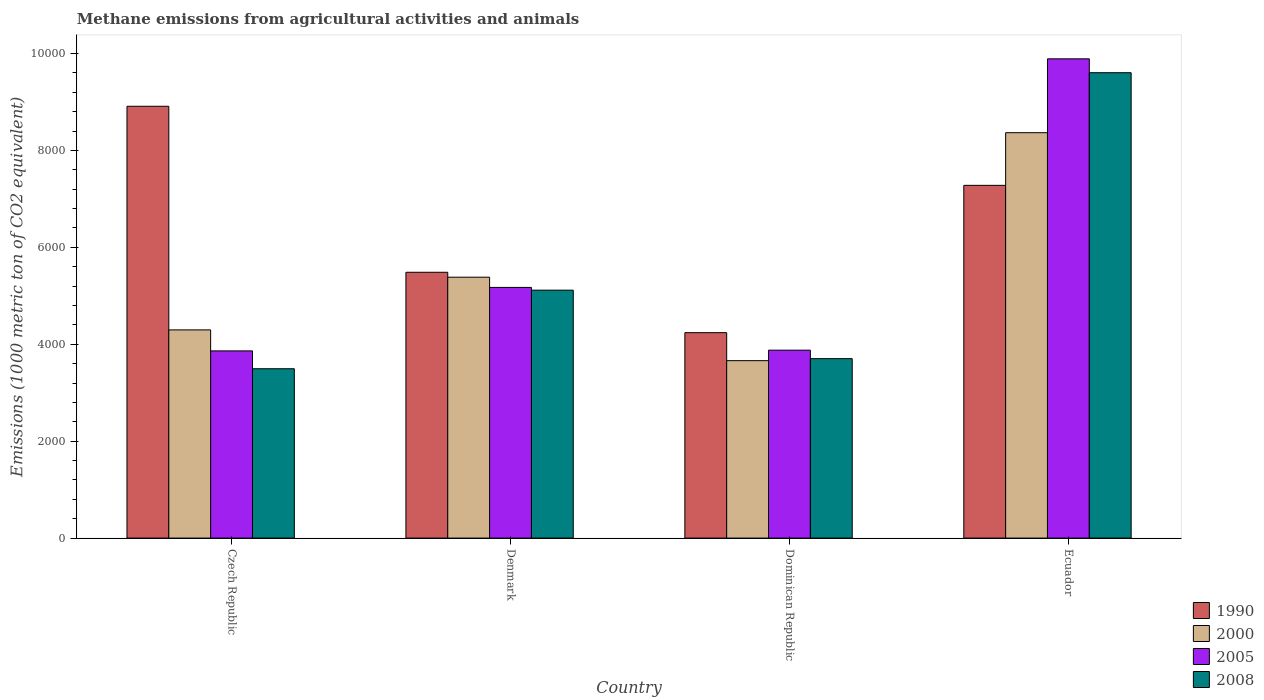How many groups of bars are there?
Ensure brevity in your answer.  4. Are the number of bars per tick equal to the number of legend labels?
Ensure brevity in your answer.  Yes. What is the label of the 1st group of bars from the left?
Offer a very short reply. Czech Republic. What is the amount of methane emitted in 2000 in Dominican Republic?
Offer a very short reply. 3661.8. Across all countries, what is the maximum amount of methane emitted in 2005?
Keep it short and to the point. 9891. Across all countries, what is the minimum amount of methane emitted in 2000?
Your answer should be very brief. 3661.8. In which country was the amount of methane emitted in 2000 maximum?
Make the answer very short. Ecuador. In which country was the amount of methane emitted in 1990 minimum?
Your answer should be compact. Dominican Republic. What is the total amount of methane emitted in 2000 in the graph?
Offer a very short reply. 2.17e+04. What is the difference between the amount of methane emitted in 2000 in Czech Republic and that in Dominican Republic?
Your answer should be very brief. 634.9. What is the difference between the amount of methane emitted in 1990 in Czech Republic and the amount of methane emitted in 2000 in Dominican Republic?
Your answer should be compact. 5250.2. What is the average amount of methane emitted in 2005 per country?
Provide a short and direct response. 5701.62. What is the difference between the amount of methane emitted of/in 2000 and amount of methane emitted of/in 2005 in Denmark?
Make the answer very short. 211.1. What is the ratio of the amount of methane emitted in 2000 in Denmark to that in Ecuador?
Ensure brevity in your answer.  0.64. Is the amount of methane emitted in 2000 in Czech Republic less than that in Denmark?
Your answer should be compact. Yes. Is the difference between the amount of methane emitted in 2000 in Czech Republic and Dominican Republic greater than the difference between the amount of methane emitted in 2005 in Czech Republic and Dominican Republic?
Offer a very short reply. Yes. What is the difference between the highest and the second highest amount of methane emitted in 2008?
Make the answer very short. -4488.1. What is the difference between the highest and the lowest amount of methane emitted in 1990?
Keep it short and to the point. 4672.2. What does the 4th bar from the left in Ecuador represents?
Offer a terse response. 2008. How many countries are there in the graph?
Provide a short and direct response. 4. Are the values on the major ticks of Y-axis written in scientific E-notation?
Your response must be concise. No. How many legend labels are there?
Offer a terse response. 4. How are the legend labels stacked?
Ensure brevity in your answer.  Vertical. What is the title of the graph?
Offer a terse response. Methane emissions from agricultural activities and animals. Does "1989" appear as one of the legend labels in the graph?
Provide a short and direct response. No. What is the label or title of the Y-axis?
Offer a terse response. Emissions (1000 metric ton of CO2 equivalent). What is the Emissions (1000 metric ton of CO2 equivalent) of 1990 in Czech Republic?
Offer a terse response. 8912. What is the Emissions (1000 metric ton of CO2 equivalent) of 2000 in Czech Republic?
Your response must be concise. 4296.7. What is the Emissions (1000 metric ton of CO2 equivalent) in 2005 in Czech Republic?
Make the answer very short. 3863.4. What is the Emissions (1000 metric ton of CO2 equivalent) in 2008 in Czech Republic?
Give a very brief answer. 3495.2. What is the Emissions (1000 metric ton of CO2 equivalent) in 1990 in Denmark?
Your response must be concise. 5486.2. What is the Emissions (1000 metric ton of CO2 equivalent) of 2000 in Denmark?
Give a very brief answer. 5384.6. What is the Emissions (1000 metric ton of CO2 equivalent) of 2005 in Denmark?
Provide a short and direct response. 5173.5. What is the Emissions (1000 metric ton of CO2 equivalent) of 2008 in Denmark?
Give a very brief answer. 5116.7. What is the Emissions (1000 metric ton of CO2 equivalent) of 1990 in Dominican Republic?
Make the answer very short. 4239.8. What is the Emissions (1000 metric ton of CO2 equivalent) of 2000 in Dominican Republic?
Ensure brevity in your answer.  3661.8. What is the Emissions (1000 metric ton of CO2 equivalent) in 2005 in Dominican Republic?
Offer a very short reply. 3878.6. What is the Emissions (1000 metric ton of CO2 equivalent) in 2008 in Dominican Republic?
Your answer should be very brief. 3703.5. What is the Emissions (1000 metric ton of CO2 equivalent) of 1990 in Ecuador?
Offer a very short reply. 7280. What is the Emissions (1000 metric ton of CO2 equivalent) of 2000 in Ecuador?
Your answer should be compact. 8366.7. What is the Emissions (1000 metric ton of CO2 equivalent) of 2005 in Ecuador?
Your answer should be compact. 9891. What is the Emissions (1000 metric ton of CO2 equivalent) in 2008 in Ecuador?
Your answer should be very brief. 9604.8. Across all countries, what is the maximum Emissions (1000 metric ton of CO2 equivalent) in 1990?
Give a very brief answer. 8912. Across all countries, what is the maximum Emissions (1000 metric ton of CO2 equivalent) in 2000?
Provide a succinct answer. 8366.7. Across all countries, what is the maximum Emissions (1000 metric ton of CO2 equivalent) in 2005?
Ensure brevity in your answer.  9891. Across all countries, what is the maximum Emissions (1000 metric ton of CO2 equivalent) in 2008?
Provide a short and direct response. 9604.8. Across all countries, what is the minimum Emissions (1000 metric ton of CO2 equivalent) in 1990?
Make the answer very short. 4239.8. Across all countries, what is the minimum Emissions (1000 metric ton of CO2 equivalent) of 2000?
Your answer should be very brief. 3661.8. Across all countries, what is the minimum Emissions (1000 metric ton of CO2 equivalent) in 2005?
Ensure brevity in your answer.  3863.4. Across all countries, what is the minimum Emissions (1000 metric ton of CO2 equivalent) of 2008?
Ensure brevity in your answer.  3495.2. What is the total Emissions (1000 metric ton of CO2 equivalent) in 1990 in the graph?
Provide a succinct answer. 2.59e+04. What is the total Emissions (1000 metric ton of CO2 equivalent) in 2000 in the graph?
Your answer should be compact. 2.17e+04. What is the total Emissions (1000 metric ton of CO2 equivalent) in 2005 in the graph?
Your answer should be very brief. 2.28e+04. What is the total Emissions (1000 metric ton of CO2 equivalent) of 2008 in the graph?
Keep it short and to the point. 2.19e+04. What is the difference between the Emissions (1000 metric ton of CO2 equivalent) in 1990 in Czech Republic and that in Denmark?
Offer a terse response. 3425.8. What is the difference between the Emissions (1000 metric ton of CO2 equivalent) of 2000 in Czech Republic and that in Denmark?
Your answer should be very brief. -1087.9. What is the difference between the Emissions (1000 metric ton of CO2 equivalent) of 2005 in Czech Republic and that in Denmark?
Ensure brevity in your answer.  -1310.1. What is the difference between the Emissions (1000 metric ton of CO2 equivalent) in 2008 in Czech Republic and that in Denmark?
Your answer should be compact. -1621.5. What is the difference between the Emissions (1000 metric ton of CO2 equivalent) in 1990 in Czech Republic and that in Dominican Republic?
Your answer should be very brief. 4672.2. What is the difference between the Emissions (1000 metric ton of CO2 equivalent) of 2000 in Czech Republic and that in Dominican Republic?
Provide a succinct answer. 634.9. What is the difference between the Emissions (1000 metric ton of CO2 equivalent) of 2005 in Czech Republic and that in Dominican Republic?
Keep it short and to the point. -15.2. What is the difference between the Emissions (1000 metric ton of CO2 equivalent) in 2008 in Czech Republic and that in Dominican Republic?
Keep it short and to the point. -208.3. What is the difference between the Emissions (1000 metric ton of CO2 equivalent) in 1990 in Czech Republic and that in Ecuador?
Provide a short and direct response. 1632. What is the difference between the Emissions (1000 metric ton of CO2 equivalent) of 2000 in Czech Republic and that in Ecuador?
Give a very brief answer. -4070. What is the difference between the Emissions (1000 metric ton of CO2 equivalent) in 2005 in Czech Republic and that in Ecuador?
Offer a terse response. -6027.6. What is the difference between the Emissions (1000 metric ton of CO2 equivalent) in 2008 in Czech Republic and that in Ecuador?
Give a very brief answer. -6109.6. What is the difference between the Emissions (1000 metric ton of CO2 equivalent) in 1990 in Denmark and that in Dominican Republic?
Your answer should be very brief. 1246.4. What is the difference between the Emissions (1000 metric ton of CO2 equivalent) in 2000 in Denmark and that in Dominican Republic?
Make the answer very short. 1722.8. What is the difference between the Emissions (1000 metric ton of CO2 equivalent) of 2005 in Denmark and that in Dominican Republic?
Your response must be concise. 1294.9. What is the difference between the Emissions (1000 metric ton of CO2 equivalent) in 2008 in Denmark and that in Dominican Republic?
Give a very brief answer. 1413.2. What is the difference between the Emissions (1000 metric ton of CO2 equivalent) of 1990 in Denmark and that in Ecuador?
Your response must be concise. -1793.8. What is the difference between the Emissions (1000 metric ton of CO2 equivalent) of 2000 in Denmark and that in Ecuador?
Ensure brevity in your answer.  -2982.1. What is the difference between the Emissions (1000 metric ton of CO2 equivalent) in 2005 in Denmark and that in Ecuador?
Provide a succinct answer. -4717.5. What is the difference between the Emissions (1000 metric ton of CO2 equivalent) in 2008 in Denmark and that in Ecuador?
Keep it short and to the point. -4488.1. What is the difference between the Emissions (1000 metric ton of CO2 equivalent) in 1990 in Dominican Republic and that in Ecuador?
Offer a very short reply. -3040.2. What is the difference between the Emissions (1000 metric ton of CO2 equivalent) in 2000 in Dominican Republic and that in Ecuador?
Provide a succinct answer. -4704.9. What is the difference between the Emissions (1000 metric ton of CO2 equivalent) of 2005 in Dominican Republic and that in Ecuador?
Give a very brief answer. -6012.4. What is the difference between the Emissions (1000 metric ton of CO2 equivalent) in 2008 in Dominican Republic and that in Ecuador?
Provide a succinct answer. -5901.3. What is the difference between the Emissions (1000 metric ton of CO2 equivalent) of 1990 in Czech Republic and the Emissions (1000 metric ton of CO2 equivalent) of 2000 in Denmark?
Your answer should be compact. 3527.4. What is the difference between the Emissions (1000 metric ton of CO2 equivalent) of 1990 in Czech Republic and the Emissions (1000 metric ton of CO2 equivalent) of 2005 in Denmark?
Give a very brief answer. 3738.5. What is the difference between the Emissions (1000 metric ton of CO2 equivalent) of 1990 in Czech Republic and the Emissions (1000 metric ton of CO2 equivalent) of 2008 in Denmark?
Ensure brevity in your answer.  3795.3. What is the difference between the Emissions (1000 metric ton of CO2 equivalent) in 2000 in Czech Republic and the Emissions (1000 metric ton of CO2 equivalent) in 2005 in Denmark?
Make the answer very short. -876.8. What is the difference between the Emissions (1000 metric ton of CO2 equivalent) of 2000 in Czech Republic and the Emissions (1000 metric ton of CO2 equivalent) of 2008 in Denmark?
Ensure brevity in your answer.  -820. What is the difference between the Emissions (1000 metric ton of CO2 equivalent) of 2005 in Czech Republic and the Emissions (1000 metric ton of CO2 equivalent) of 2008 in Denmark?
Provide a short and direct response. -1253.3. What is the difference between the Emissions (1000 metric ton of CO2 equivalent) in 1990 in Czech Republic and the Emissions (1000 metric ton of CO2 equivalent) in 2000 in Dominican Republic?
Ensure brevity in your answer.  5250.2. What is the difference between the Emissions (1000 metric ton of CO2 equivalent) of 1990 in Czech Republic and the Emissions (1000 metric ton of CO2 equivalent) of 2005 in Dominican Republic?
Provide a short and direct response. 5033.4. What is the difference between the Emissions (1000 metric ton of CO2 equivalent) in 1990 in Czech Republic and the Emissions (1000 metric ton of CO2 equivalent) in 2008 in Dominican Republic?
Your answer should be compact. 5208.5. What is the difference between the Emissions (1000 metric ton of CO2 equivalent) of 2000 in Czech Republic and the Emissions (1000 metric ton of CO2 equivalent) of 2005 in Dominican Republic?
Your answer should be very brief. 418.1. What is the difference between the Emissions (1000 metric ton of CO2 equivalent) of 2000 in Czech Republic and the Emissions (1000 metric ton of CO2 equivalent) of 2008 in Dominican Republic?
Your response must be concise. 593.2. What is the difference between the Emissions (1000 metric ton of CO2 equivalent) of 2005 in Czech Republic and the Emissions (1000 metric ton of CO2 equivalent) of 2008 in Dominican Republic?
Offer a terse response. 159.9. What is the difference between the Emissions (1000 metric ton of CO2 equivalent) in 1990 in Czech Republic and the Emissions (1000 metric ton of CO2 equivalent) in 2000 in Ecuador?
Your answer should be compact. 545.3. What is the difference between the Emissions (1000 metric ton of CO2 equivalent) of 1990 in Czech Republic and the Emissions (1000 metric ton of CO2 equivalent) of 2005 in Ecuador?
Your answer should be compact. -979. What is the difference between the Emissions (1000 metric ton of CO2 equivalent) in 1990 in Czech Republic and the Emissions (1000 metric ton of CO2 equivalent) in 2008 in Ecuador?
Your answer should be compact. -692.8. What is the difference between the Emissions (1000 metric ton of CO2 equivalent) in 2000 in Czech Republic and the Emissions (1000 metric ton of CO2 equivalent) in 2005 in Ecuador?
Provide a short and direct response. -5594.3. What is the difference between the Emissions (1000 metric ton of CO2 equivalent) of 2000 in Czech Republic and the Emissions (1000 metric ton of CO2 equivalent) of 2008 in Ecuador?
Provide a succinct answer. -5308.1. What is the difference between the Emissions (1000 metric ton of CO2 equivalent) in 2005 in Czech Republic and the Emissions (1000 metric ton of CO2 equivalent) in 2008 in Ecuador?
Offer a very short reply. -5741.4. What is the difference between the Emissions (1000 metric ton of CO2 equivalent) in 1990 in Denmark and the Emissions (1000 metric ton of CO2 equivalent) in 2000 in Dominican Republic?
Offer a very short reply. 1824.4. What is the difference between the Emissions (1000 metric ton of CO2 equivalent) in 1990 in Denmark and the Emissions (1000 metric ton of CO2 equivalent) in 2005 in Dominican Republic?
Give a very brief answer. 1607.6. What is the difference between the Emissions (1000 metric ton of CO2 equivalent) of 1990 in Denmark and the Emissions (1000 metric ton of CO2 equivalent) of 2008 in Dominican Republic?
Your answer should be very brief. 1782.7. What is the difference between the Emissions (1000 metric ton of CO2 equivalent) in 2000 in Denmark and the Emissions (1000 metric ton of CO2 equivalent) in 2005 in Dominican Republic?
Your answer should be compact. 1506. What is the difference between the Emissions (1000 metric ton of CO2 equivalent) of 2000 in Denmark and the Emissions (1000 metric ton of CO2 equivalent) of 2008 in Dominican Republic?
Make the answer very short. 1681.1. What is the difference between the Emissions (1000 metric ton of CO2 equivalent) of 2005 in Denmark and the Emissions (1000 metric ton of CO2 equivalent) of 2008 in Dominican Republic?
Your answer should be very brief. 1470. What is the difference between the Emissions (1000 metric ton of CO2 equivalent) of 1990 in Denmark and the Emissions (1000 metric ton of CO2 equivalent) of 2000 in Ecuador?
Ensure brevity in your answer.  -2880.5. What is the difference between the Emissions (1000 metric ton of CO2 equivalent) of 1990 in Denmark and the Emissions (1000 metric ton of CO2 equivalent) of 2005 in Ecuador?
Offer a very short reply. -4404.8. What is the difference between the Emissions (1000 metric ton of CO2 equivalent) of 1990 in Denmark and the Emissions (1000 metric ton of CO2 equivalent) of 2008 in Ecuador?
Your answer should be compact. -4118.6. What is the difference between the Emissions (1000 metric ton of CO2 equivalent) in 2000 in Denmark and the Emissions (1000 metric ton of CO2 equivalent) in 2005 in Ecuador?
Provide a succinct answer. -4506.4. What is the difference between the Emissions (1000 metric ton of CO2 equivalent) of 2000 in Denmark and the Emissions (1000 metric ton of CO2 equivalent) of 2008 in Ecuador?
Your response must be concise. -4220.2. What is the difference between the Emissions (1000 metric ton of CO2 equivalent) of 2005 in Denmark and the Emissions (1000 metric ton of CO2 equivalent) of 2008 in Ecuador?
Provide a short and direct response. -4431.3. What is the difference between the Emissions (1000 metric ton of CO2 equivalent) in 1990 in Dominican Republic and the Emissions (1000 metric ton of CO2 equivalent) in 2000 in Ecuador?
Ensure brevity in your answer.  -4126.9. What is the difference between the Emissions (1000 metric ton of CO2 equivalent) of 1990 in Dominican Republic and the Emissions (1000 metric ton of CO2 equivalent) of 2005 in Ecuador?
Give a very brief answer. -5651.2. What is the difference between the Emissions (1000 metric ton of CO2 equivalent) of 1990 in Dominican Republic and the Emissions (1000 metric ton of CO2 equivalent) of 2008 in Ecuador?
Your response must be concise. -5365. What is the difference between the Emissions (1000 metric ton of CO2 equivalent) in 2000 in Dominican Republic and the Emissions (1000 metric ton of CO2 equivalent) in 2005 in Ecuador?
Your answer should be compact. -6229.2. What is the difference between the Emissions (1000 metric ton of CO2 equivalent) of 2000 in Dominican Republic and the Emissions (1000 metric ton of CO2 equivalent) of 2008 in Ecuador?
Give a very brief answer. -5943. What is the difference between the Emissions (1000 metric ton of CO2 equivalent) in 2005 in Dominican Republic and the Emissions (1000 metric ton of CO2 equivalent) in 2008 in Ecuador?
Give a very brief answer. -5726.2. What is the average Emissions (1000 metric ton of CO2 equivalent) of 1990 per country?
Provide a succinct answer. 6479.5. What is the average Emissions (1000 metric ton of CO2 equivalent) in 2000 per country?
Give a very brief answer. 5427.45. What is the average Emissions (1000 metric ton of CO2 equivalent) in 2005 per country?
Keep it short and to the point. 5701.62. What is the average Emissions (1000 metric ton of CO2 equivalent) in 2008 per country?
Offer a very short reply. 5480.05. What is the difference between the Emissions (1000 metric ton of CO2 equivalent) of 1990 and Emissions (1000 metric ton of CO2 equivalent) of 2000 in Czech Republic?
Ensure brevity in your answer.  4615.3. What is the difference between the Emissions (1000 metric ton of CO2 equivalent) in 1990 and Emissions (1000 metric ton of CO2 equivalent) in 2005 in Czech Republic?
Keep it short and to the point. 5048.6. What is the difference between the Emissions (1000 metric ton of CO2 equivalent) in 1990 and Emissions (1000 metric ton of CO2 equivalent) in 2008 in Czech Republic?
Ensure brevity in your answer.  5416.8. What is the difference between the Emissions (1000 metric ton of CO2 equivalent) of 2000 and Emissions (1000 metric ton of CO2 equivalent) of 2005 in Czech Republic?
Provide a short and direct response. 433.3. What is the difference between the Emissions (1000 metric ton of CO2 equivalent) of 2000 and Emissions (1000 metric ton of CO2 equivalent) of 2008 in Czech Republic?
Keep it short and to the point. 801.5. What is the difference between the Emissions (1000 metric ton of CO2 equivalent) of 2005 and Emissions (1000 metric ton of CO2 equivalent) of 2008 in Czech Republic?
Your answer should be very brief. 368.2. What is the difference between the Emissions (1000 metric ton of CO2 equivalent) in 1990 and Emissions (1000 metric ton of CO2 equivalent) in 2000 in Denmark?
Your response must be concise. 101.6. What is the difference between the Emissions (1000 metric ton of CO2 equivalent) in 1990 and Emissions (1000 metric ton of CO2 equivalent) in 2005 in Denmark?
Ensure brevity in your answer.  312.7. What is the difference between the Emissions (1000 metric ton of CO2 equivalent) in 1990 and Emissions (1000 metric ton of CO2 equivalent) in 2008 in Denmark?
Provide a succinct answer. 369.5. What is the difference between the Emissions (1000 metric ton of CO2 equivalent) of 2000 and Emissions (1000 metric ton of CO2 equivalent) of 2005 in Denmark?
Provide a succinct answer. 211.1. What is the difference between the Emissions (1000 metric ton of CO2 equivalent) in 2000 and Emissions (1000 metric ton of CO2 equivalent) in 2008 in Denmark?
Your answer should be compact. 267.9. What is the difference between the Emissions (1000 metric ton of CO2 equivalent) in 2005 and Emissions (1000 metric ton of CO2 equivalent) in 2008 in Denmark?
Make the answer very short. 56.8. What is the difference between the Emissions (1000 metric ton of CO2 equivalent) in 1990 and Emissions (1000 metric ton of CO2 equivalent) in 2000 in Dominican Republic?
Keep it short and to the point. 578. What is the difference between the Emissions (1000 metric ton of CO2 equivalent) in 1990 and Emissions (1000 metric ton of CO2 equivalent) in 2005 in Dominican Republic?
Your response must be concise. 361.2. What is the difference between the Emissions (1000 metric ton of CO2 equivalent) in 1990 and Emissions (1000 metric ton of CO2 equivalent) in 2008 in Dominican Republic?
Your answer should be compact. 536.3. What is the difference between the Emissions (1000 metric ton of CO2 equivalent) in 2000 and Emissions (1000 metric ton of CO2 equivalent) in 2005 in Dominican Republic?
Your answer should be very brief. -216.8. What is the difference between the Emissions (1000 metric ton of CO2 equivalent) in 2000 and Emissions (1000 metric ton of CO2 equivalent) in 2008 in Dominican Republic?
Keep it short and to the point. -41.7. What is the difference between the Emissions (1000 metric ton of CO2 equivalent) of 2005 and Emissions (1000 metric ton of CO2 equivalent) of 2008 in Dominican Republic?
Your response must be concise. 175.1. What is the difference between the Emissions (1000 metric ton of CO2 equivalent) in 1990 and Emissions (1000 metric ton of CO2 equivalent) in 2000 in Ecuador?
Provide a short and direct response. -1086.7. What is the difference between the Emissions (1000 metric ton of CO2 equivalent) in 1990 and Emissions (1000 metric ton of CO2 equivalent) in 2005 in Ecuador?
Your answer should be compact. -2611. What is the difference between the Emissions (1000 metric ton of CO2 equivalent) in 1990 and Emissions (1000 metric ton of CO2 equivalent) in 2008 in Ecuador?
Your response must be concise. -2324.8. What is the difference between the Emissions (1000 metric ton of CO2 equivalent) of 2000 and Emissions (1000 metric ton of CO2 equivalent) of 2005 in Ecuador?
Provide a succinct answer. -1524.3. What is the difference between the Emissions (1000 metric ton of CO2 equivalent) of 2000 and Emissions (1000 metric ton of CO2 equivalent) of 2008 in Ecuador?
Your answer should be compact. -1238.1. What is the difference between the Emissions (1000 metric ton of CO2 equivalent) in 2005 and Emissions (1000 metric ton of CO2 equivalent) in 2008 in Ecuador?
Provide a succinct answer. 286.2. What is the ratio of the Emissions (1000 metric ton of CO2 equivalent) in 1990 in Czech Republic to that in Denmark?
Your answer should be very brief. 1.62. What is the ratio of the Emissions (1000 metric ton of CO2 equivalent) of 2000 in Czech Republic to that in Denmark?
Your response must be concise. 0.8. What is the ratio of the Emissions (1000 metric ton of CO2 equivalent) in 2005 in Czech Republic to that in Denmark?
Make the answer very short. 0.75. What is the ratio of the Emissions (1000 metric ton of CO2 equivalent) in 2008 in Czech Republic to that in Denmark?
Offer a very short reply. 0.68. What is the ratio of the Emissions (1000 metric ton of CO2 equivalent) in 1990 in Czech Republic to that in Dominican Republic?
Give a very brief answer. 2.1. What is the ratio of the Emissions (1000 metric ton of CO2 equivalent) of 2000 in Czech Republic to that in Dominican Republic?
Your answer should be compact. 1.17. What is the ratio of the Emissions (1000 metric ton of CO2 equivalent) of 2005 in Czech Republic to that in Dominican Republic?
Keep it short and to the point. 1. What is the ratio of the Emissions (1000 metric ton of CO2 equivalent) in 2008 in Czech Republic to that in Dominican Republic?
Offer a terse response. 0.94. What is the ratio of the Emissions (1000 metric ton of CO2 equivalent) of 1990 in Czech Republic to that in Ecuador?
Give a very brief answer. 1.22. What is the ratio of the Emissions (1000 metric ton of CO2 equivalent) of 2000 in Czech Republic to that in Ecuador?
Your answer should be compact. 0.51. What is the ratio of the Emissions (1000 metric ton of CO2 equivalent) of 2005 in Czech Republic to that in Ecuador?
Provide a short and direct response. 0.39. What is the ratio of the Emissions (1000 metric ton of CO2 equivalent) in 2008 in Czech Republic to that in Ecuador?
Ensure brevity in your answer.  0.36. What is the ratio of the Emissions (1000 metric ton of CO2 equivalent) of 1990 in Denmark to that in Dominican Republic?
Give a very brief answer. 1.29. What is the ratio of the Emissions (1000 metric ton of CO2 equivalent) in 2000 in Denmark to that in Dominican Republic?
Offer a very short reply. 1.47. What is the ratio of the Emissions (1000 metric ton of CO2 equivalent) in 2005 in Denmark to that in Dominican Republic?
Give a very brief answer. 1.33. What is the ratio of the Emissions (1000 metric ton of CO2 equivalent) of 2008 in Denmark to that in Dominican Republic?
Your answer should be compact. 1.38. What is the ratio of the Emissions (1000 metric ton of CO2 equivalent) of 1990 in Denmark to that in Ecuador?
Offer a terse response. 0.75. What is the ratio of the Emissions (1000 metric ton of CO2 equivalent) of 2000 in Denmark to that in Ecuador?
Provide a short and direct response. 0.64. What is the ratio of the Emissions (1000 metric ton of CO2 equivalent) in 2005 in Denmark to that in Ecuador?
Make the answer very short. 0.52. What is the ratio of the Emissions (1000 metric ton of CO2 equivalent) in 2008 in Denmark to that in Ecuador?
Offer a terse response. 0.53. What is the ratio of the Emissions (1000 metric ton of CO2 equivalent) of 1990 in Dominican Republic to that in Ecuador?
Provide a short and direct response. 0.58. What is the ratio of the Emissions (1000 metric ton of CO2 equivalent) of 2000 in Dominican Republic to that in Ecuador?
Keep it short and to the point. 0.44. What is the ratio of the Emissions (1000 metric ton of CO2 equivalent) of 2005 in Dominican Republic to that in Ecuador?
Provide a short and direct response. 0.39. What is the ratio of the Emissions (1000 metric ton of CO2 equivalent) of 2008 in Dominican Republic to that in Ecuador?
Your answer should be very brief. 0.39. What is the difference between the highest and the second highest Emissions (1000 metric ton of CO2 equivalent) of 1990?
Give a very brief answer. 1632. What is the difference between the highest and the second highest Emissions (1000 metric ton of CO2 equivalent) of 2000?
Provide a succinct answer. 2982.1. What is the difference between the highest and the second highest Emissions (1000 metric ton of CO2 equivalent) in 2005?
Provide a short and direct response. 4717.5. What is the difference between the highest and the second highest Emissions (1000 metric ton of CO2 equivalent) of 2008?
Provide a succinct answer. 4488.1. What is the difference between the highest and the lowest Emissions (1000 metric ton of CO2 equivalent) in 1990?
Keep it short and to the point. 4672.2. What is the difference between the highest and the lowest Emissions (1000 metric ton of CO2 equivalent) in 2000?
Provide a succinct answer. 4704.9. What is the difference between the highest and the lowest Emissions (1000 metric ton of CO2 equivalent) in 2005?
Make the answer very short. 6027.6. What is the difference between the highest and the lowest Emissions (1000 metric ton of CO2 equivalent) of 2008?
Make the answer very short. 6109.6. 